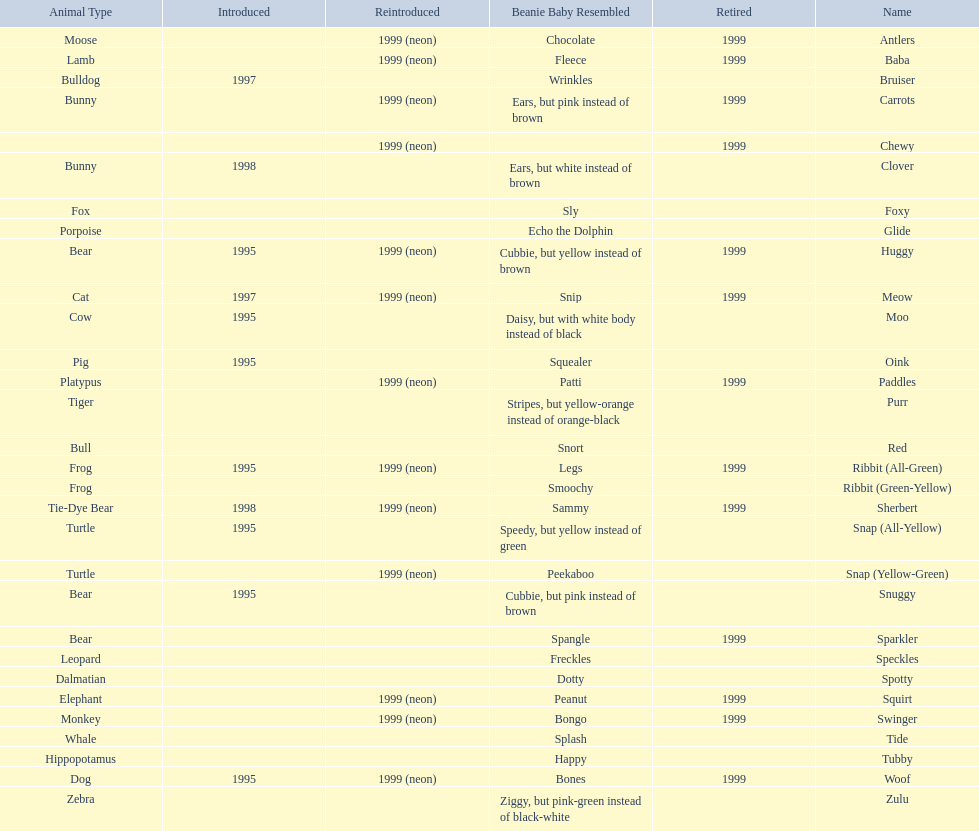What animals are pillow pals? Moose, Lamb, Bulldog, Bunny, Bunny, Fox, Porpoise, Bear, Cat, Cow, Pig, Platypus, Tiger, Bull, Frog, Frog, Tie-Dye Bear, Turtle, Turtle, Bear, Bear, Leopard, Dalmatian, Elephant, Monkey, Whale, Hippopotamus, Dog, Zebra. What is the name of the dalmatian? Spotty. 